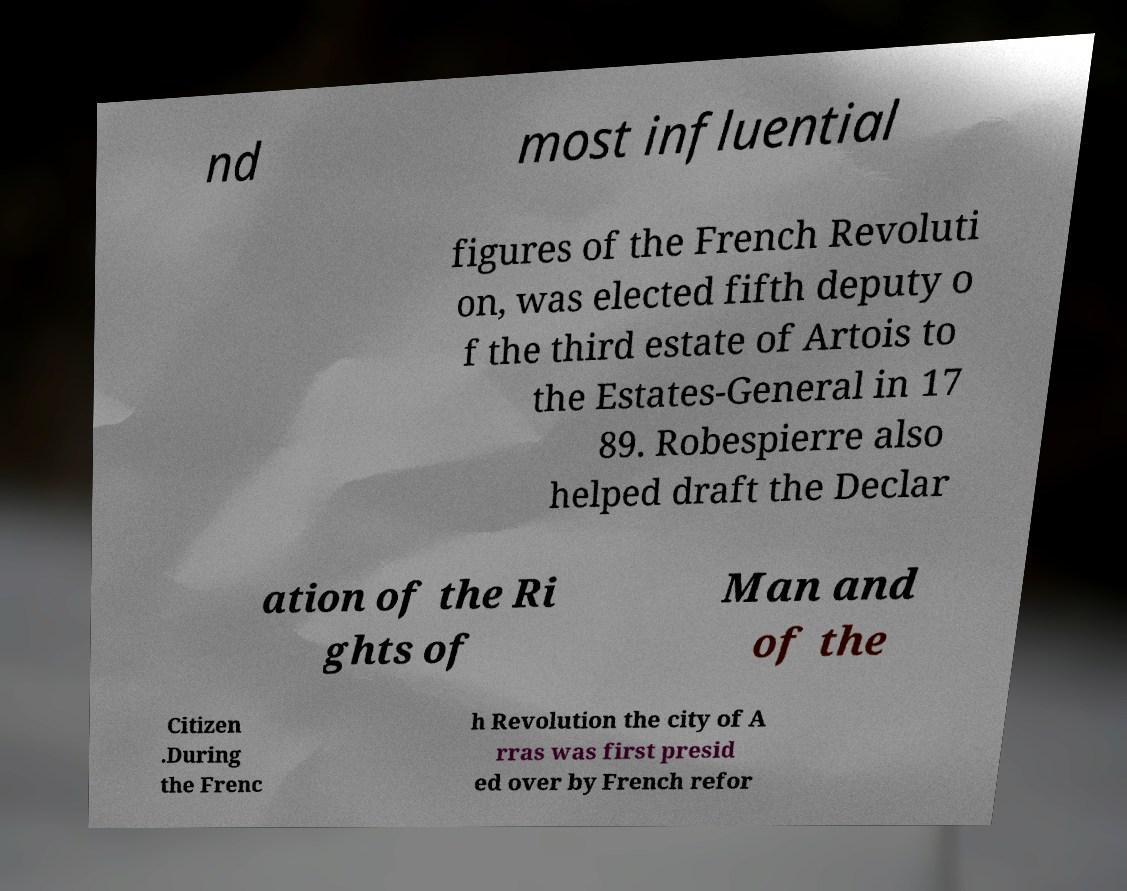Could you assist in decoding the text presented in this image and type it out clearly? nd most influential figures of the French Revoluti on, was elected fifth deputy o f the third estate of Artois to the Estates-General in 17 89. Robespierre also helped draft the Declar ation of the Ri ghts of Man and of the Citizen .During the Frenc h Revolution the city of A rras was first presid ed over by French refor 